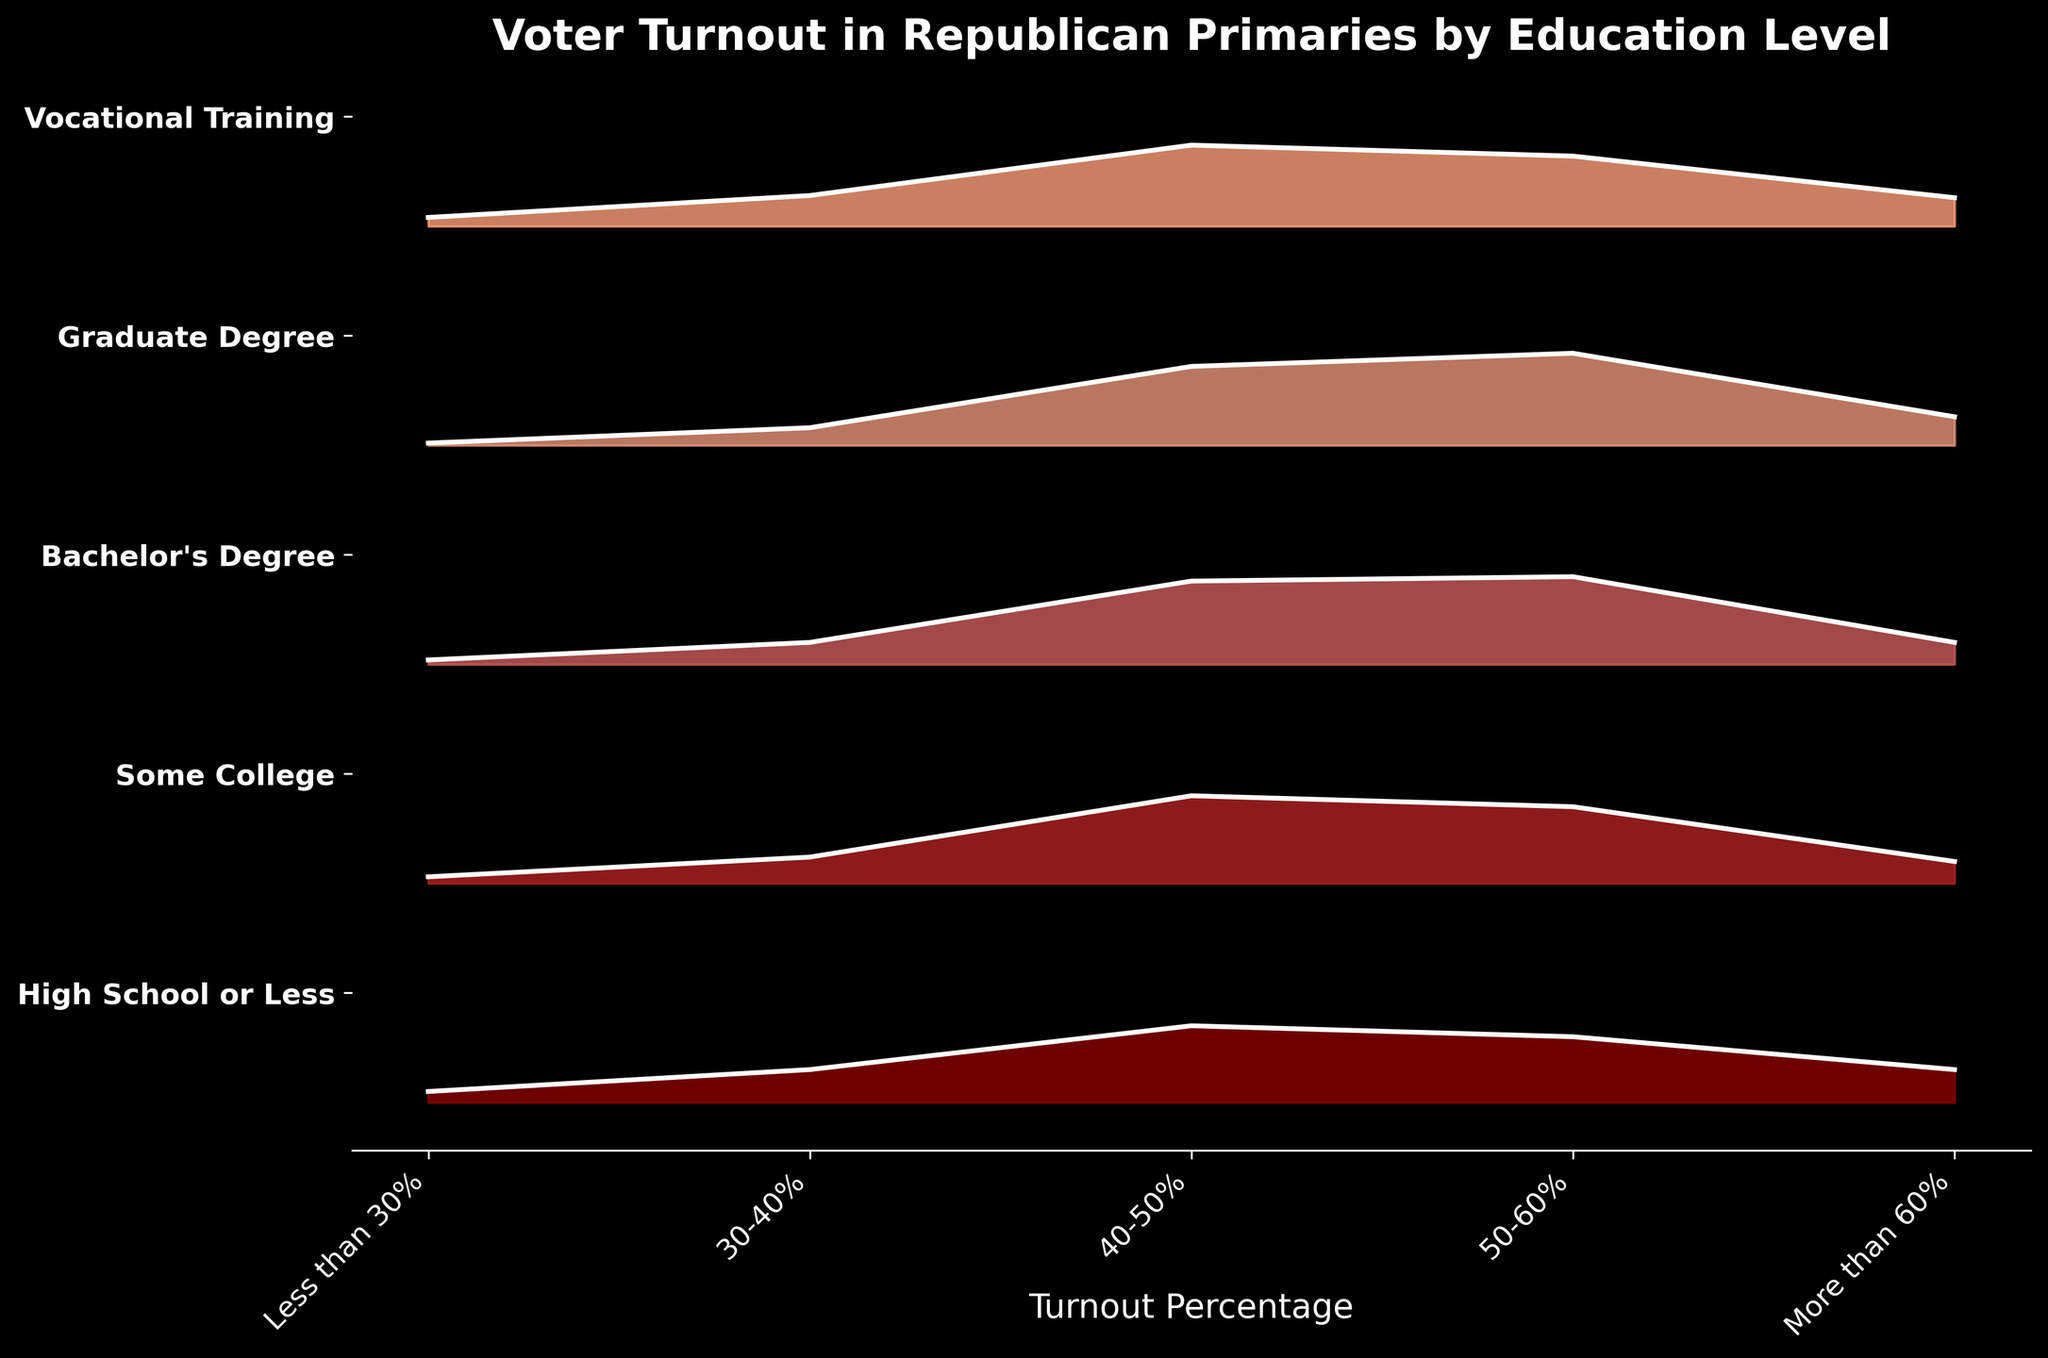What is the title of the figure? The title of the figure is usually displayed at the top and describes what the data represents. In this case, the title is clear and concise.
Answer: Voter Turnout in Republican Primaries by Education Level What are the categories on the x-axis? The categories on the x-axis represent different turnout percentages. They are labeled with ranges of values.
Answer: Less than 30%, 30-40%, 40-50%, 50-60%, More than 60% Which education group has the highest proportion of 50-60% voter turnout? To find this, we look for the education level where the 50-60% range has the highest value. This can be seen by the height of the peaks around the 50-60% category.
Answer: Graduate Degree How does the voter turnout for "High School or Less" compare between the "30-40%" and "50-60%" categories? We compare the values corresponding to the "High School or Less" education level for both the "30-40%" and "50-60%" categories.
Answer: 30-40% is 0.15 and 50-60% is 0.30, so 50-60% is higher Which education level shows the lowest voter turnout in the "Less than 30%" category? We need to look for the smallest value under the "Less than 30%" category across all education levels.
Answer: Graduate Degree For "Some College" education level, what is the total proportion of voter turnout in the "Less than 30%" and "More than 60%" categories combined? We sum the values of the "Less than 30%" and "More than 60%" categories for "Some College". 0.03 (Less than 30%) + 0.10 (More than 60%) = 0.13.
Answer: 0.13 By how much does the voter turnout for "Bachelor's Degree" in the "40-50%" category exceed that in the "Less than 30%" category? Subtract the value of the "Less than 30%" category from the "40-50%" category for "Bachelor's Degree". 0.38 (40-50%) - 0.02 (Less than 30%) = 0.36.
Answer: 0.36 What is the approximate average voter turnout for "Vocational Training" across all categories? We sum the values for "Vocational Training" across all categories and then divide by the number of categories. (0.04 + 0.14 + 0.37 + 0.32 + 0.13)/5 = 1.00/5 = 0.20.
Answer: 0.20 In which category do all education levels show the highest voter turnout? We look at each category and identify the one where all the peaks are highest in comparison.
Answer: 40-50% 